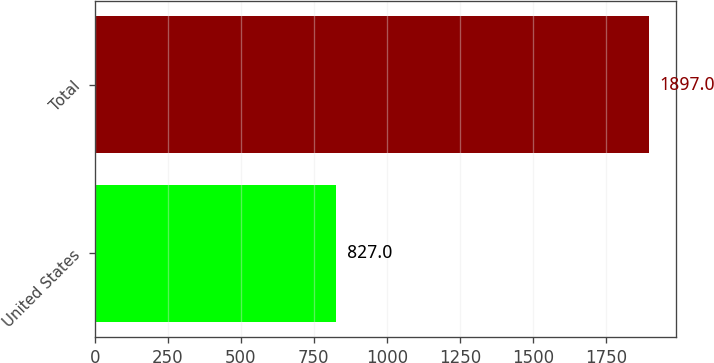<chart> <loc_0><loc_0><loc_500><loc_500><bar_chart><fcel>United States<fcel>Total<nl><fcel>827<fcel>1897<nl></chart> 